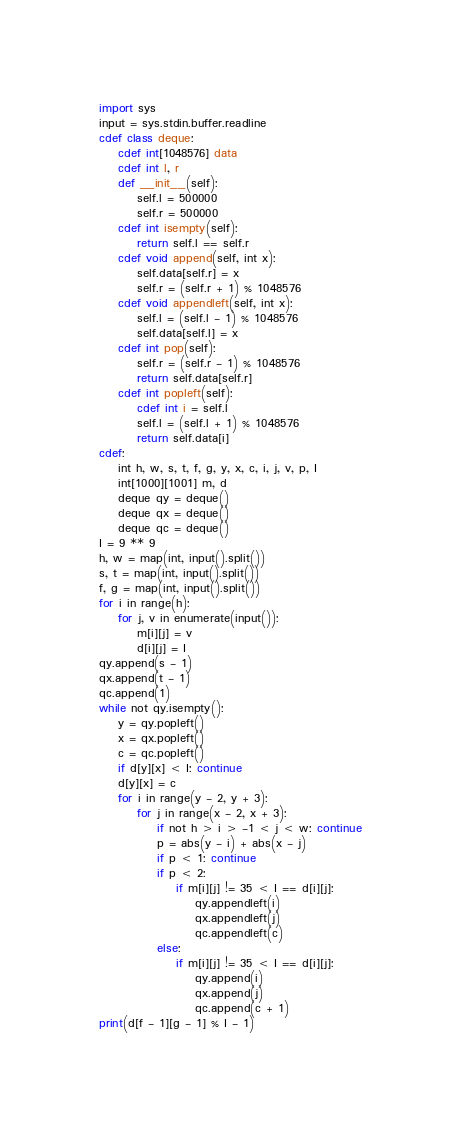Convert code to text. <code><loc_0><loc_0><loc_500><loc_500><_Cython_>import sys
input = sys.stdin.buffer.readline
cdef class deque:
    cdef int[1048576] data
    cdef int l, r
    def __init__(self):
        self.l = 500000
        self.r = 500000
    cdef int isempty(self):
        return self.l == self.r
    cdef void append(self, int x):
        self.data[self.r] = x
        self.r = (self.r + 1) % 1048576
    cdef void appendleft(self, int x):
        self.l = (self.l - 1) % 1048576
        self.data[self.l] = x
    cdef int pop(self):
        self.r = (self.r - 1) % 1048576
        return self.data[self.r]
    cdef int popleft(self):
        cdef int i = self.l
        self.l = (self.l + 1) % 1048576
        return self.data[i]
cdef:
    int h, w, s, t, f, g, y, x, c, i, j, v, p, I
    int[1000][1001] m, d
    deque qy = deque()
    deque qx = deque()
    deque qc = deque()
I = 9 ** 9
h, w = map(int, input().split())
s, t = map(int, input().split())
f, g = map(int, input().split())
for i in range(h):
    for j, v in enumerate(input()):
        m[i][j] = v
        d[i][j] = I
qy.append(s - 1)
qx.append(t - 1)
qc.append(1)
while not qy.isempty():
    y = qy.popleft()
    x = qx.popleft()
    c = qc.popleft()
    if d[y][x] < I: continue
    d[y][x] = c
    for i in range(y - 2, y + 3):
        for j in range(x - 2, x + 3):
            if not h > i > -1 < j < w: continue
            p = abs(y - i) + abs(x - j)
            if p < 1: continue
            if p < 2:
                if m[i][j] != 35 < I == d[i][j]:
                    qy.appendleft(i)
                    qx.appendleft(j)
                    qc.appendleft(c)
            else:
                if m[i][j] != 35 < I == d[i][j]:
                    qy.append(i)
                    qx.append(j)
                    qc.append(c + 1)
print(d[f - 1][g - 1] % I - 1)</code> 